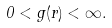Convert formula to latex. <formula><loc_0><loc_0><loc_500><loc_500>0 < g ( r ) < \infty .</formula> 